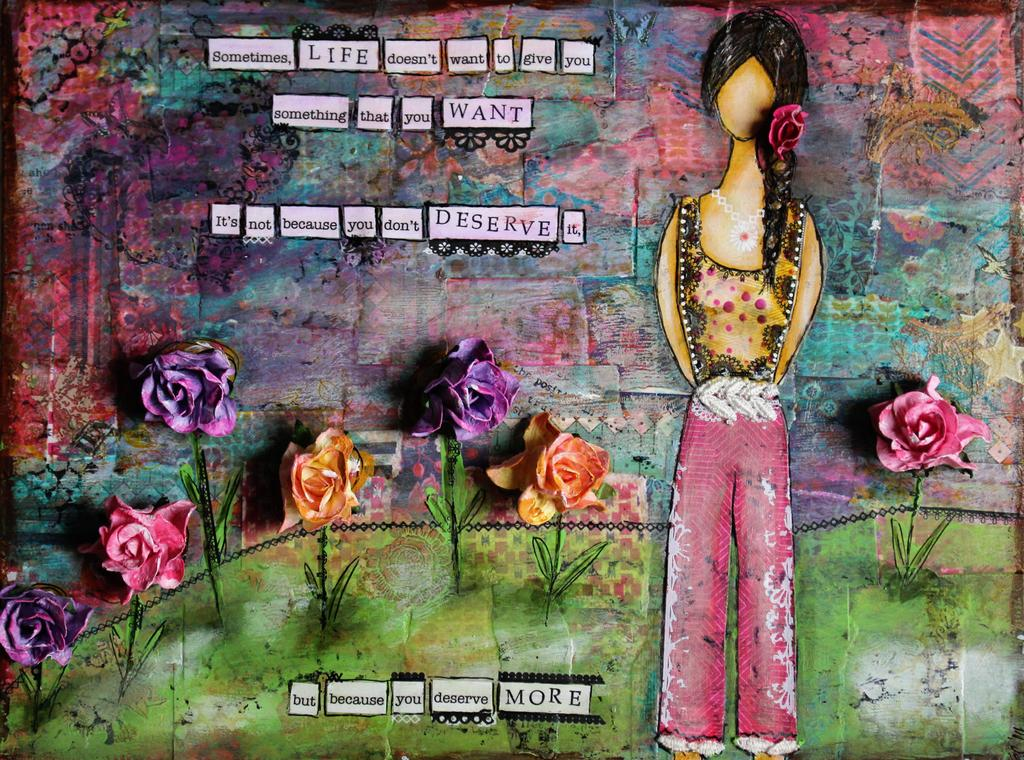What type of artwork is present in the image? There is a wall painting in the image. What other elements can be seen in the image besides the wall painting? There are flowers, pictures, and text visible in the image. What is the background of the image? There is a wall in the background of the image. What type of door is present in the image? There is no door present in the image. What caption can be seen accompanying the wall painting in the image? There is no caption visible in the image; only text is present. 